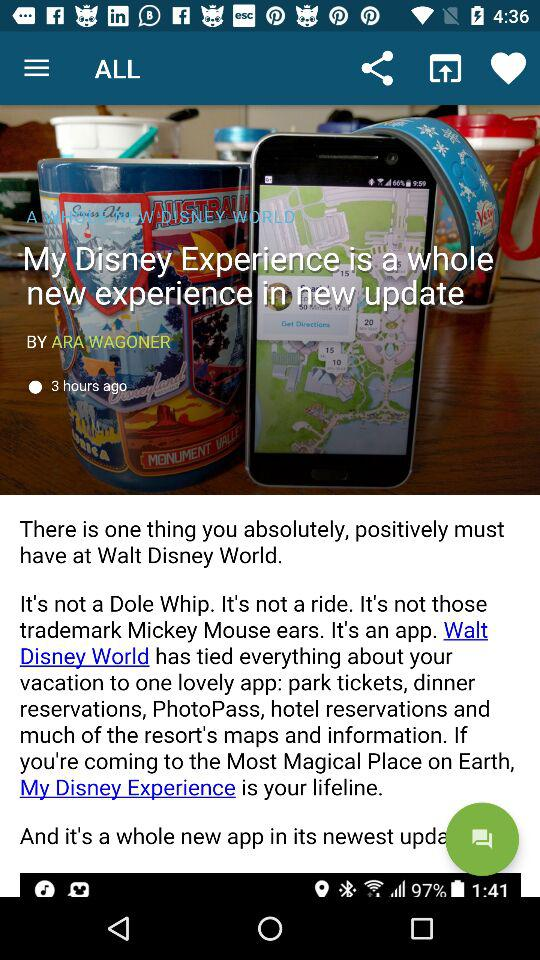What is the author name? The author name is Ara Wagoner. 